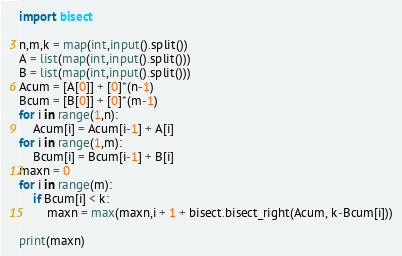<code> <loc_0><loc_0><loc_500><loc_500><_Python_>import bisect

n,m,k = map(int,input().split())
A = list(map(int,input().split()))
B = list(map(int,input().split()))
Acum = [A[0]] + [0]*(n-1)
Bcum = [B[0]] + [0]*(m-1)
for i in range(1,n):
    Acum[i] = Acum[i-1] + A[i]
for i in range(1,m):
    Bcum[i] = Bcum[i-1] + B[i]
maxn = 0
for i in range(m):
    if Bcum[i] < k:
        maxn = max(maxn,i + 1 + bisect.bisect_right(Acum, k-Bcum[i]))

print(maxn)</code> 